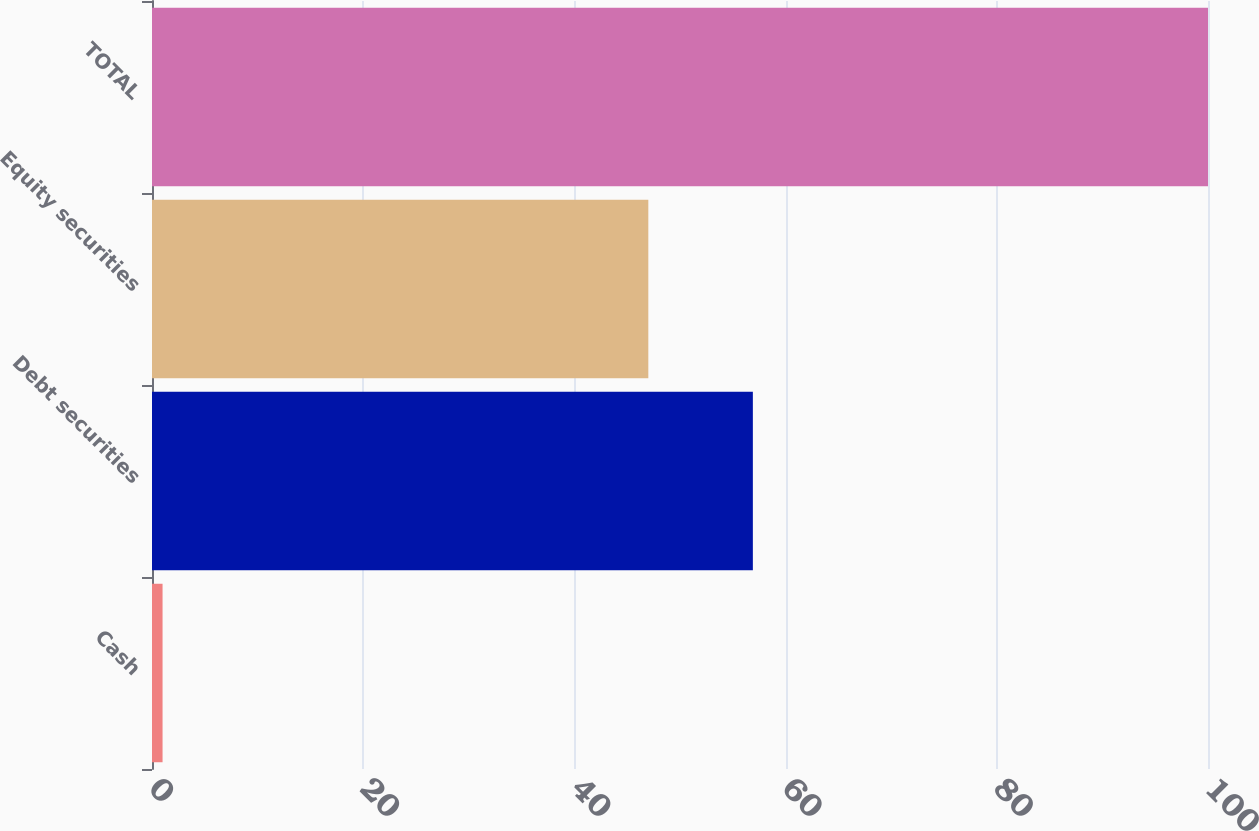Convert chart to OTSL. <chart><loc_0><loc_0><loc_500><loc_500><bar_chart><fcel>Cash<fcel>Debt securities<fcel>Equity securities<fcel>TOTAL<nl><fcel>1<fcel>56.9<fcel>47<fcel>100<nl></chart> 